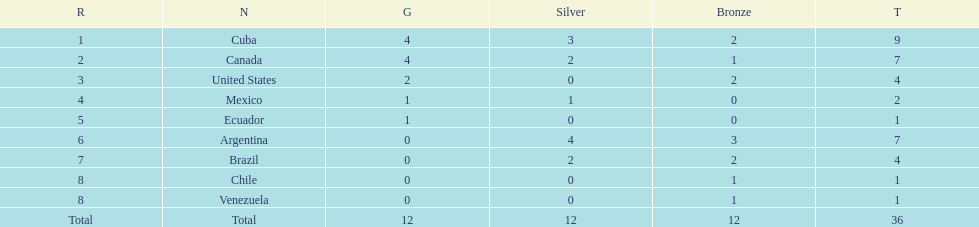Which country triumphed with gold but didn't succeed in getting silver? United States. 